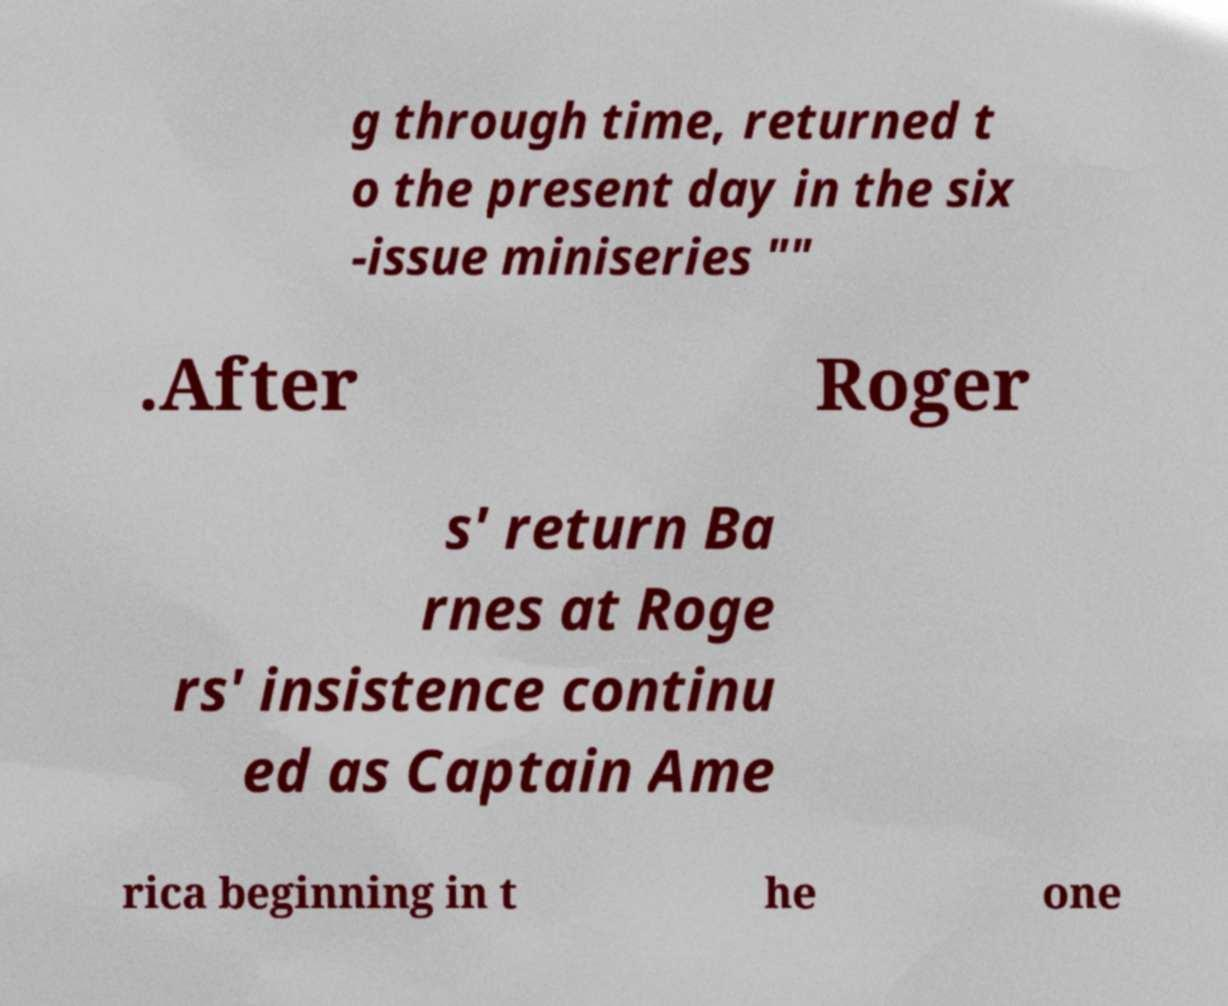I need the written content from this picture converted into text. Can you do that? g through time, returned t o the present day in the six -issue miniseries "" .After Roger s' return Ba rnes at Roge rs' insistence continu ed as Captain Ame rica beginning in t he one 